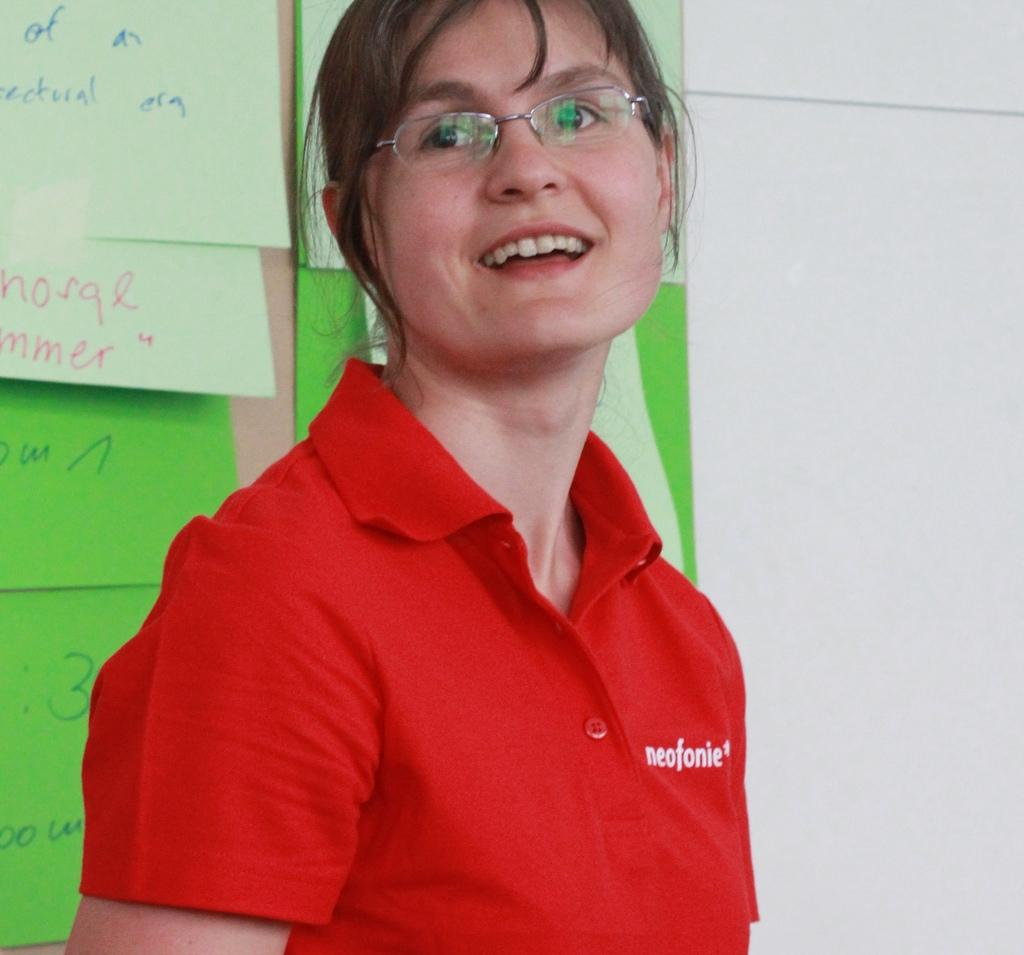What is the main subject of the image? There is a person standing in the image. Where is the person standing in relation to the wall? The person is standing near a wall. What is attached to the wall in the image? There are pages with text attached to the wall. What type of market can be seen in the image? There is no market present in the image; it features a person standing near a wall with pages with text attached to it. How many cracks are visible on the wall in the image? There is no mention of cracks on the wall in the image; only the person and the pages with text are present. 